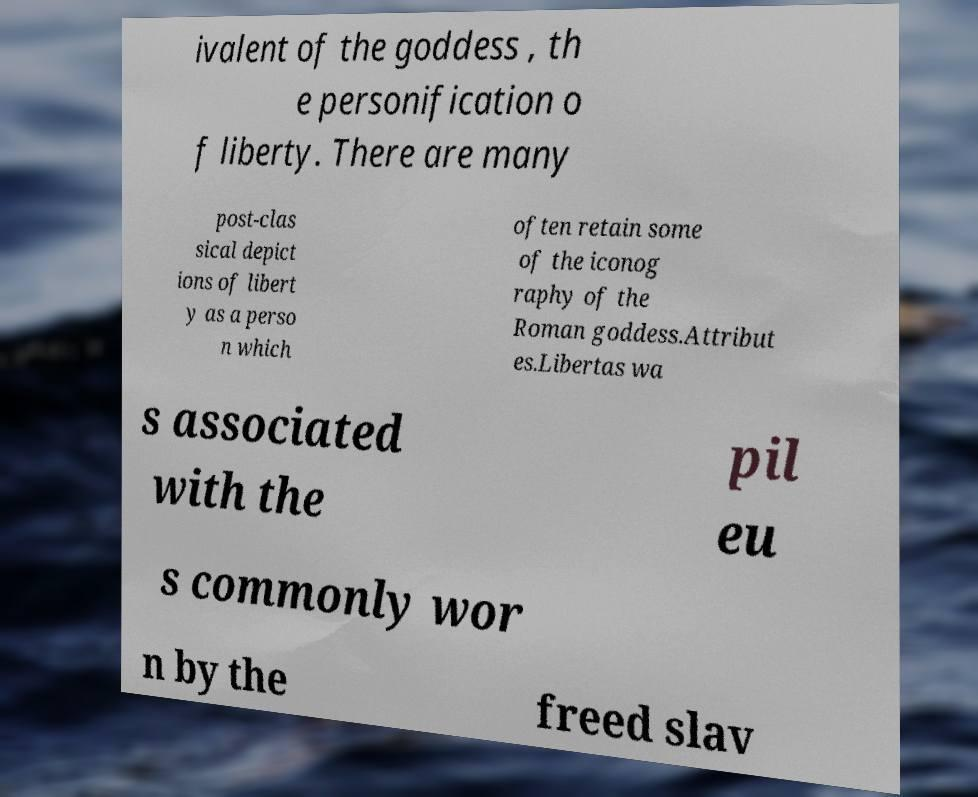Could you extract and type out the text from this image? ivalent of the goddess , th e personification o f liberty. There are many post-clas sical depict ions of libert y as a perso n which often retain some of the iconog raphy of the Roman goddess.Attribut es.Libertas wa s associated with the pil eu s commonly wor n by the freed slav 